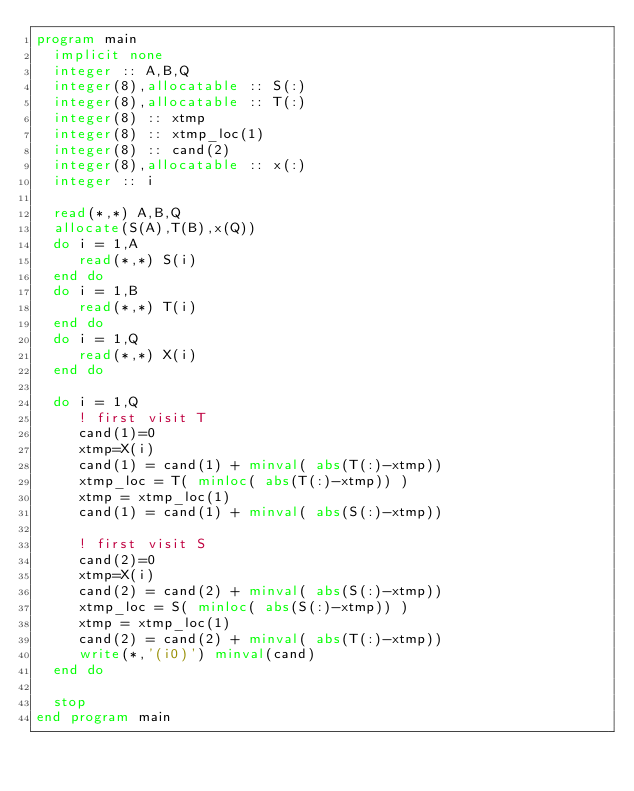Convert code to text. <code><loc_0><loc_0><loc_500><loc_500><_FORTRAN_>program main
  implicit none
  integer :: A,B,Q
  integer(8),allocatable :: S(:)
  integer(8),allocatable :: T(:)
  integer(8) :: xtmp
  integer(8) :: xtmp_loc(1)
  integer(8) :: cand(2)
  integer(8),allocatable :: x(:)
  integer :: i
  
  read(*,*) A,B,Q
  allocate(S(A),T(B),x(Q))
  do i = 1,A
     read(*,*) S(i)
  end do
  do i = 1,B
     read(*,*) T(i)
  end do
  do i = 1,Q
     read(*,*) X(i)
  end do

  do i = 1,Q
     ! first visit T
     cand(1)=0
     xtmp=X(i)
     cand(1) = cand(1) + minval( abs(T(:)-xtmp))
     xtmp_loc = T( minloc( abs(T(:)-xtmp)) )
     xtmp = xtmp_loc(1)
     cand(1) = cand(1) + minval( abs(S(:)-xtmp))

     ! first visit S
     cand(2)=0
     xtmp=X(i)
     cand(2) = cand(2) + minval( abs(S(:)-xtmp))
     xtmp_loc = S( minloc( abs(S(:)-xtmp)) )
     xtmp = xtmp_loc(1)
     cand(2) = cand(2) + minval( abs(T(:)-xtmp))
     write(*,'(i0)') minval(cand)
  end do
     
  stop
end program main
</code> 